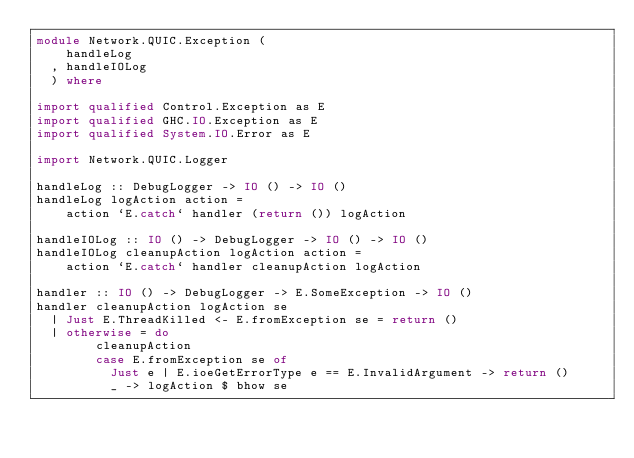<code> <loc_0><loc_0><loc_500><loc_500><_Haskell_>module Network.QUIC.Exception (
    handleLog
  , handleIOLog
  ) where

import qualified Control.Exception as E
import qualified GHC.IO.Exception as E
import qualified System.IO.Error as E

import Network.QUIC.Logger

handleLog :: DebugLogger -> IO () -> IO ()
handleLog logAction action =
    action `E.catch` handler (return ()) logAction

handleIOLog :: IO () -> DebugLogger -> IO () -> IO ()
handleIOLog cleanupAction logAction action =
    action `E.catch` handler cleanupAction logAction

handler :: IO () -> DebugLogger -> E.SomeException -> IO ()
handler cleanupAction logAction se
  | Just E.ThreadKilled <- E.fromException se = return ()
  | otherwise = do
        cleanupAction
        case E.fromException se of
          Just e | E.ioeGetErrorType e == E.InvalidArgument -> return ()
          _ -> logAction $ bhow se
</code> 